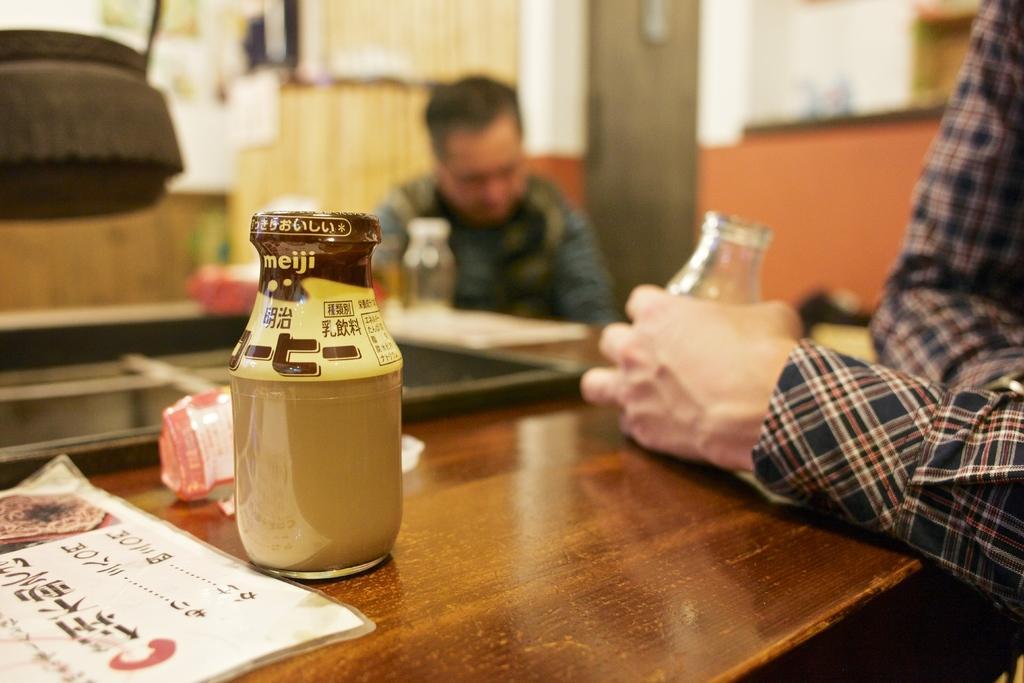In one or two sentences, can you explain what this image depicts? In this image I can see a bottle and other objects on a table. I can also seen there are two men holding a glass in his hand. 